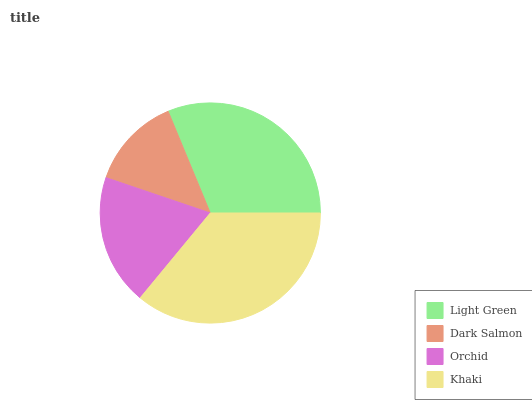Is Dark Salmon the minimum?
Answer yes or no. Yes. Is Khaki the maximum?
Answer yes or no. Yes. Is Orchid the minimum?
Answer yes or no. No. Is Orchid the maximum?
Answer yes or no. No. Is Orchid greater than Dark Salmon?
Answer yes or no. Yes. Is Dark Salmon less than Orchid?
Answer yes or no. Yes. Is Dark Salmon greater than Orchid?
Answer yes or no. No. Is Orchid less than Dark Salmon?
Answer yes or no. No. Is Light Green the high median?
Answer yes or no. Yes. Is Orchid the low median?
Answer yes or no. Yes. Is Dark Salmon the high median?
Answer yes or no. No. Is Khaki the low median?
Answer yes or no. No. 